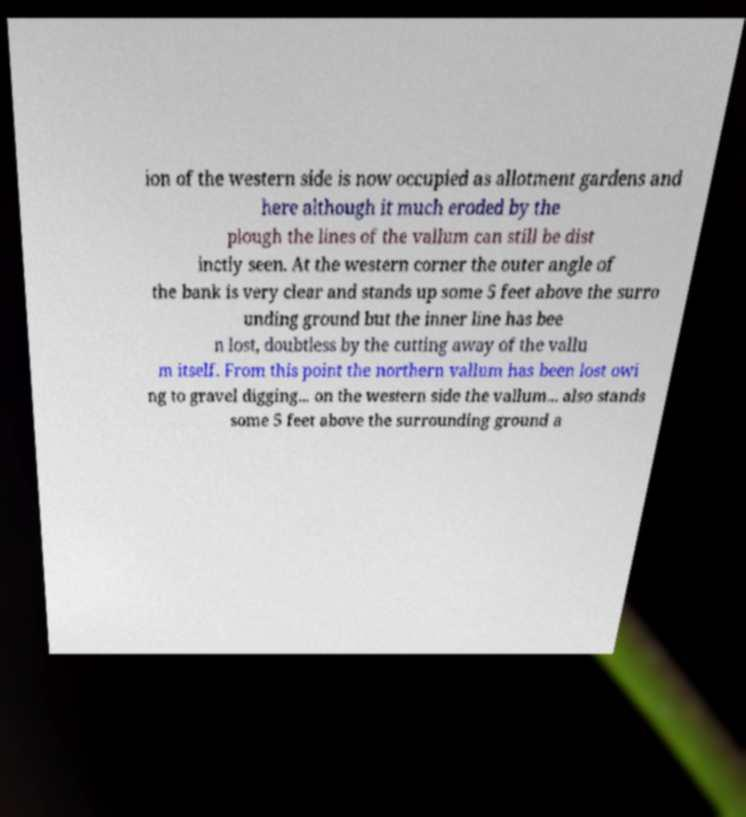Please read and relay the text visible in this image. What does it say? ion of the western side is now occupied as allotment gardens and here although it much eroded by the plough the lines of the vallum can still be dist inctly seen. At the western corner the outer angle of the bank is very clear and stands up some 5 feet above the surro unding ground but the inner line has bee n lost, doubtless by the cutting away of the vallu m itself. From this point the northern vallum has been lost owi ng to gravel digging... on the western side the vallum... also stands some 5 feet above the surrounding ground a 